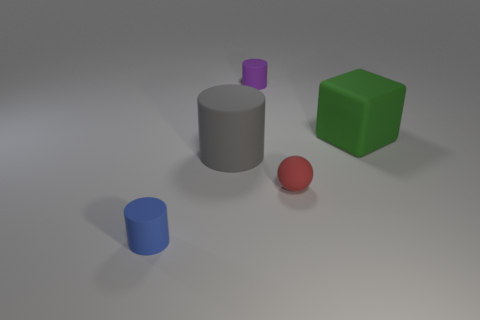Add 1 small blue things. How many objects exist? 6 Subtract all spheres. How many objects are left? 4 Add 2 matte objects. How many matte objects are left? 7 Add 2 large cubes. How many large cubes exist? 3 Subtract 0 brown spheres. How many objects are left? 5 Subtract all big things. Subtract all small blue shiny blocks. How many objects are left? 3 